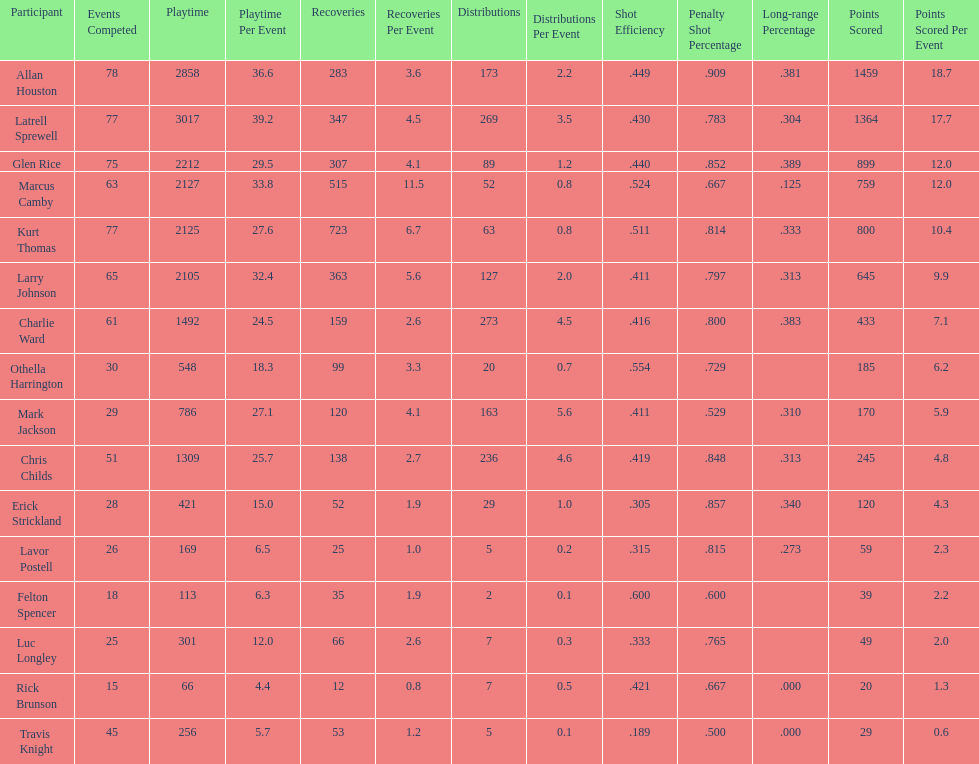Did kurt thomas play more or less than 2126 minutes? Less. Could you parse the entire table as a dict? {'header': ['Participant', 'Events Competed', 'Playtime', 'Playtime Per Event', 'Recoveries', 'Recoveries Per Event', 'Distributions', 'Distributions Per Event', 'Shot Efficiency', 'Penalty Shot Percentage', 'Long-range Percentage', 'Points Scored', 'Points Scored Per Event'], 'rows': [['Allan Houston', '78', '2858', '36.6', '283', '3.6', '173', '2.2', '.449', '.909', '.381', '1459', '18.7'], ['Latrell Sprewell', '77', '3017', '39.2', '347', '4.5', '269', '3.5', '.430', '.783', '.304', '1364', '17.7'], ['Glen Rice', '75', '2212', '29.5', '307', '4.1', '89', '1.2', '.440', '.852', '.389', '899', '12.0'], ['Marcus Camby', '63', '2127', '33.8', '515', '11.5', '52', '0.8', '.524', '.667', '.125', '759', '12.0'], ['Kurt Thomas', '77', '2125', '27.6', '723', '6.7', '63', '0.8', '.511', '.814', '.333', '800', '10.4'], ['Larry Johnson', '65', '2105', '32.4', '363', '5.6', '127', '2.0', '.411', '.797', '.313', '645', '9.9'], ['Charlie Ward', '61', '1492', '24.5', '159', '2.6', '273', '4.5', '.416', '.800', '.383', '433', '7.1'], ['Othella Harrington', '30', '548', '18.3', '99', '3.3', '20', '0.7', '.554', '.729', '', '185', '6.2'], ['Mark Jackson', '29', '786', '27.1', '120', '4.1', '163', '5.6', '.411', '.529', '.310', '170', '5.9'], ['Chris Childs', '51', '1309', '25.7', '138', '2.7', '236', '4.6', '.419', '.848', '.313', '245', '4.8'], ['Erick Strickland', '28', '421', '15.0', '52', '1.9', '29', '1.0', '.305', '.857', '.340', '120', '4.3'], ['Lavor Postell', '26', '169', '6.5', '25', '1.0', '5', '0.2', '.315', '.815', '.273', '59', '2.3'], ['Felton Spencer', '18', '113', '6.3', '35', '1.9', '2', '0.1', '.600', '.600', '', '39', '2.2'], ['Luc Longley', '25', '301', '12.0', '66', '2.6', '7', '0.3', '.333', '.765', '', '49', '2.0'], ['Rick Brunson', '15', '66', '4.4', '12', '0.8', '7', '0.5', '.421', '.667', '.000', '20', '1.3'], ['Travis Knight', '45', '256', '5.7', '53', '1.2', '5', '0.1', '.189', '.500', '.000', '29', '0.6']]} 